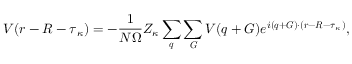<formula> <loc_0><loc_0><loc_500><loc_500>V ( r - R - \tau _ { \kappa } ) = - \frac { 1 } { N \Omega } Z _ { \kappa } \sum _ { q } \sum _ { G } V ( q + G ) e ^ { i ( q + G ) \cdot ( r - R - \tau _ { \kappa } ) } ,</formula> 